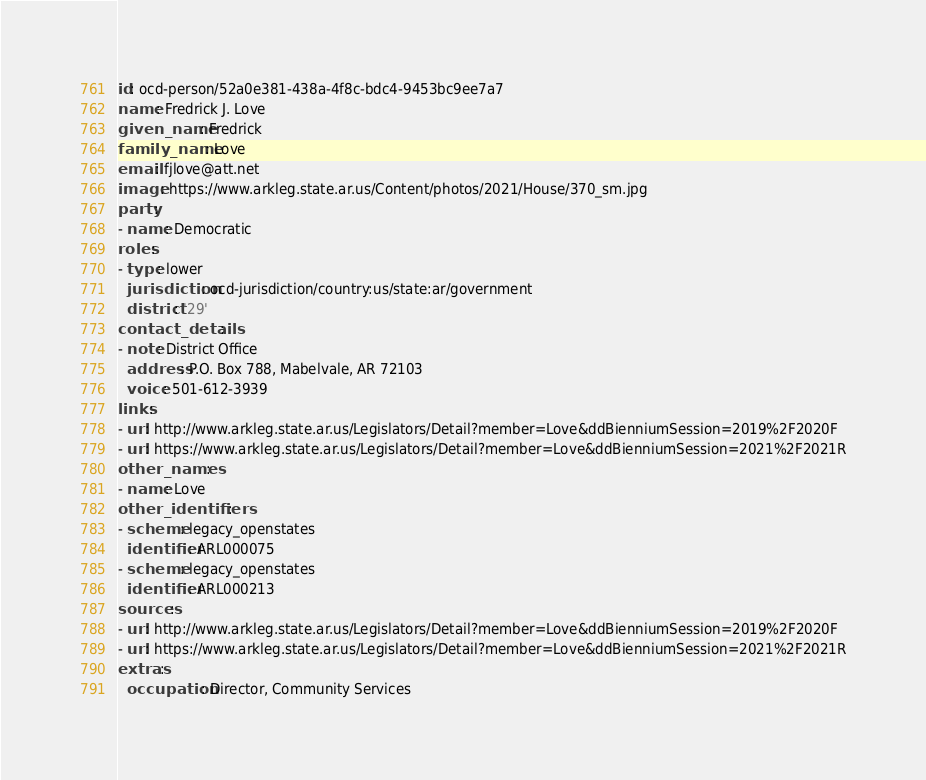Convert code to text. <code><loc_0><loc_0><loc_500><loc_500><_YAML_>id: ocd-person/52a0e381-438a-4f8c-bdc4-9453bc9ee7a7
name: Fredrick J. Love
given_name: Fredrick
family_name: Love
email: fjlove@att.net
image: https://www.arkleg.state.ar.us/Content/photos/2021/House/370_sm.jpg
party:
- name: Democratic
roles:
- type: lower
  jurisdiction: ocd-jurisdiction/country:us/state:ar/government
  district: '29'
contact_details:
- note: District Office
  address: P.O. Box 788, Mabelvale, AR 72103
  voice: 501-612-3939
links:
- url: http://www.arkleg.state.ar.us/Legislators/Detail?member=Love&ddBienniumSession=2019%2F2020F
- url: https://www.arkleg.state.ar.us/Legislators/Detail?member=Love&ddBienniumSession=2021%2F2021R
other_names:
- name: Love
other_identifiers:
- scheme: legacy_openstates
  identifier: ARL000075
- scheme: legacy_openstates
  identifier: ARL000213
sources:
- url: http://www.arkleg.state.ar.us/Legislators/Detail?member=Love&ddBienniumSession=2019%2F2020F
- url: https://www.arkleg.state.ar.us/Legislators/Detail?member=Love&ddBienniumSession=2021%2F2021R
extras:
  occupation: Director, Community Services
</code> 